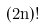<formula> <loc_0><loc_0><loc_500><loc_500>( 2 n ) !</formula> 